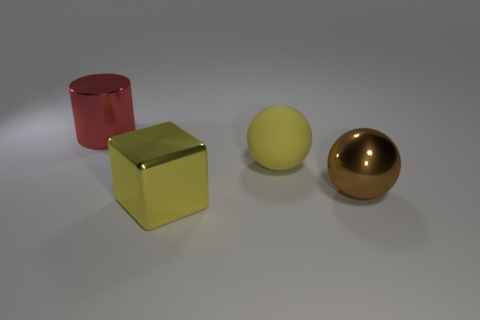There is a red object that is the same size as the yellow metal block; what is it made of?
Make the answer very short. Metal. What color is the object that is in front of the ball to the right of the ball behind the metallic sphere?
Give a very brief answer. Yellow. There is a yellow thing that is to the right of the shiny cube; does it have the same shape as the metal object to the right of the large yellow cube?
Keep it short and to the point. Yes. How many small matte spheres are there?
Offer a terse response. 0. The rubber object that is the same size as the metallic block is what color?
Provide a short and direct response. Yellow. Is the sphere that is behind the brown thing made of the same material as the yellow thing that is in front of the large rubber ball?
Provide a short and direct response. No. There is a sphere behind the big brown thing; what material is it?
Offer a terse response. Rubber. What number of things are metallic things that are in front of the large red thing or yellow objects in front of the large brown object?
Provide a short and direct response. 2. What is the material of the other big object that is the same shape as the rubber object?
Your response must be concise. Metal. Is the color of the big sphere to the left of the brown metallic ball the same as the metal object that is behind the brown ball?
Ensure brevity in your answer.  No. 